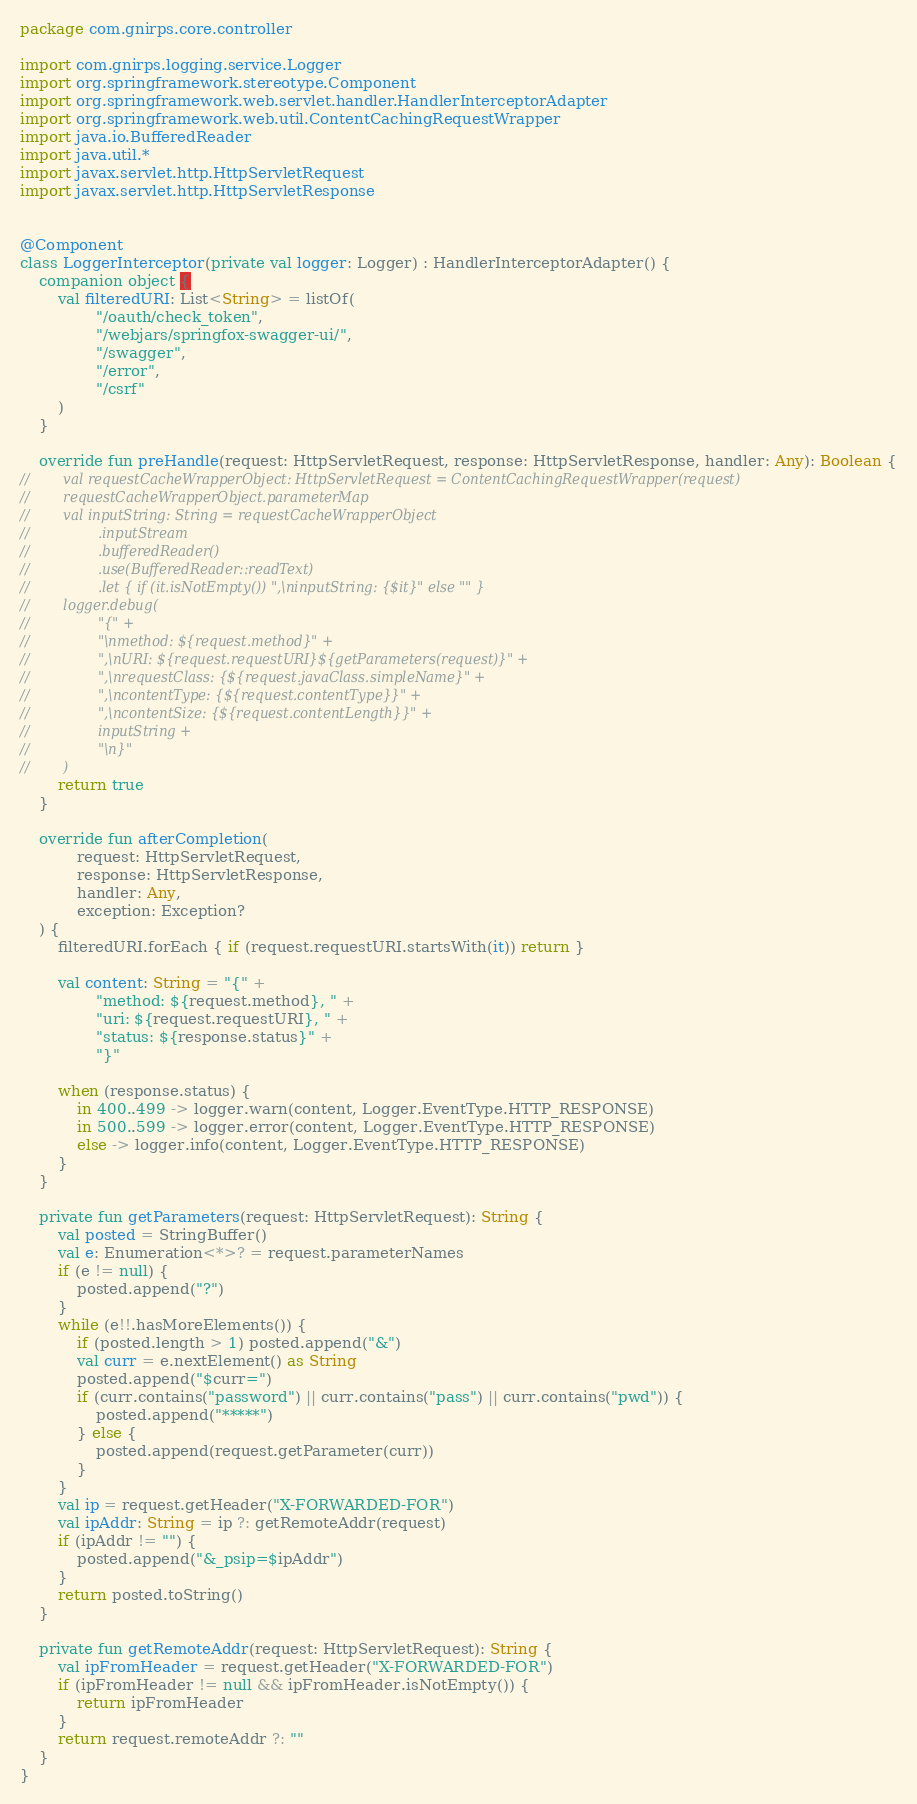Convert code to text. <code><loc_0><loc_0><loc_500><loc_500><_Kotlin_>package com.gnirps.core.controller

import com.gnirps.logging.service.Logger
import org.springframework.stereotype.Component
import org.springframework.web.servlet.handler.HandlerInterceptorAdapter
import org.springframework.web.util.ContentCachingRequestWrapper
import java.io.BufferedReader
import java.util.*
import javax.servlet.http.HttpServletRequest
import javax.servlet.http.HttpServletResponse


@Component
class LoggerInterceptor(private val logger: Logger) : HandlerInterceptorAdapter() {
    companion object {
        val filteredURI: List<String> = listOf(
                "/oauth/check_token",
                "/webjars/springfox-swagger-ui/",
                "/swagger",
                "/error",
                "/csrf"
        )
    }

    override fun preHandle(request: HttpServletRequest, response: HttpServletResponse, handler: Any): Boolean {
//        val requestCacheWrapperObject: HttpServletRequest = ContentCachingRequestWrapper(request)
//        requestCacheWrapperObject.parameterMap
//        val inputString: String = requestCacheWrapperObject
//                .inputStream
//                .bufferedReader()
//                .use(BufferedReader::readText)
//                .let { if (it.isNotEmpty()) ",\ninputString: {$it}" else "" }
//        logger.debug(
//                "{" +
//                "\nmethod: ${request.method}" +
//                ",\nURI: ${request.requestURI}${getParameters(request)}" +
//                ",\nrequestClass: {${request.javaClass.simpleName}" +
//                ",\ncontentType: {${request.contentType}}" +
//                ",\ncontentSize: {${request.contentLength}}" +
//                inputString +
//                "\n}"
//        )
        return true
    }

    override fun afterCompletion(
            request: HttpServletRequest,
            response: HttpServletResponse,
            handler: Any,
            exception: Exception?
    ) {
        filteredURI.forEach { if (request.requestURI.startsWith(it)) return }

        val content: String = "{" +
                "method: ${request.method}, " +
                "uri: ${request.requestURI}, " +
                "status: ${response.status}" +
                "}"

        when (response.status) {
            in 400..499 -> logger.warn(content, Logger.EventType.HTTP_RESPONSE)
            in 500..599 -> logger.error(content, Logger.EventType.HTTP_RESPONSE)
            else -> logger.info(content, Logger.EventType.HTTP_RESPONSE)
        }
    }

    private fun getParameters(request: HttpServletRequest): String {
        val posted = StringBuffer()
        val e: Enumeration<*>? = request.parameterNames
        if (e != null) {
            posted.append("?")
        }
        while (e!!.hasMoreElements()) {
            if (posted.length > 1) posted.append("&")
            val curr = e.nextElement() as String
            posted.append("$curr=")
            if (curr.contains("password") || curr.contains("pass") || curr.contains("pwd")) {
                posted.append("*****")
            } else {
                posted.append(request.getParameter(curr))
            }
        }
        val ip = request.getHeader("X-FORWARDED-FOR")
        val ipAddr: String = ip ?: getRemoteAddr(request)
        if (ipAddr != "") {
            posted.append("&_psip=$ipAddr")
        }
        return posted.toString()
    }

    private fun getRemoteAddr(request: HttpServletRequest): String {
        val ipFromHeader = request.getHeader("X-FORWARDED-FOR")
        if (ipFromHeader != null && ipFromHeader.isNotEmpty()) {
            return ipFromHeader
        }
        return request.remoteAddr ?: ""
    }
}
</code> 